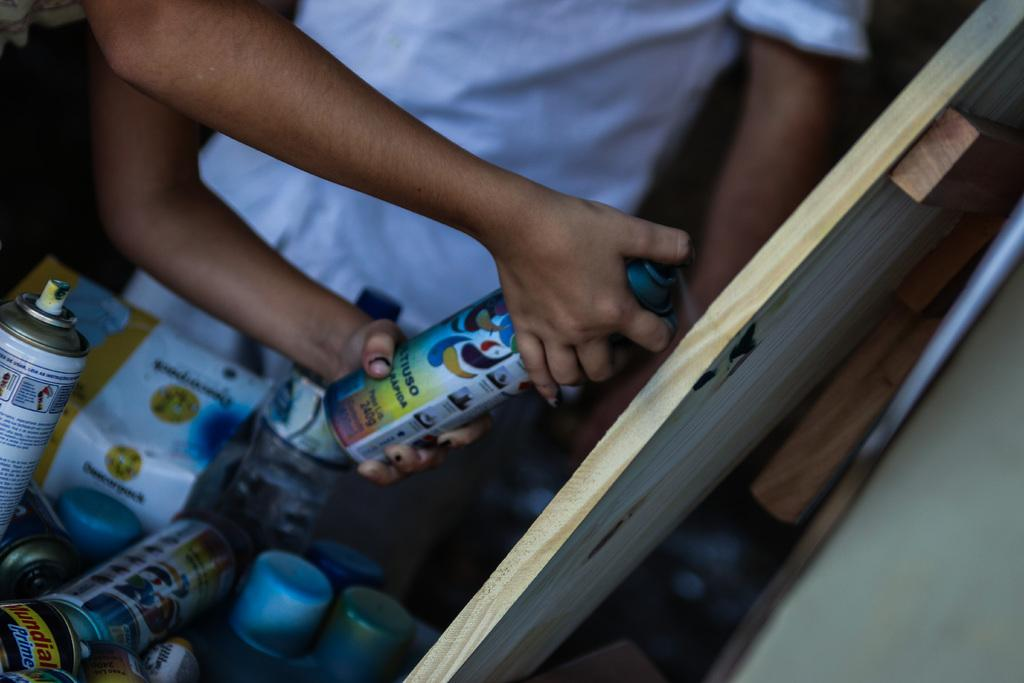What is the person in the image holding? There is a person holding an object in the image. Can you describe the setting of the image? There is another person visible in the background of the image, and there are other objects present in the background as well. What type of waste is visible in the image? There is no waste visible in the image. What is the skin condition of the person holding the object? The skin condition of the person holding the object cannot be determined from the image. 